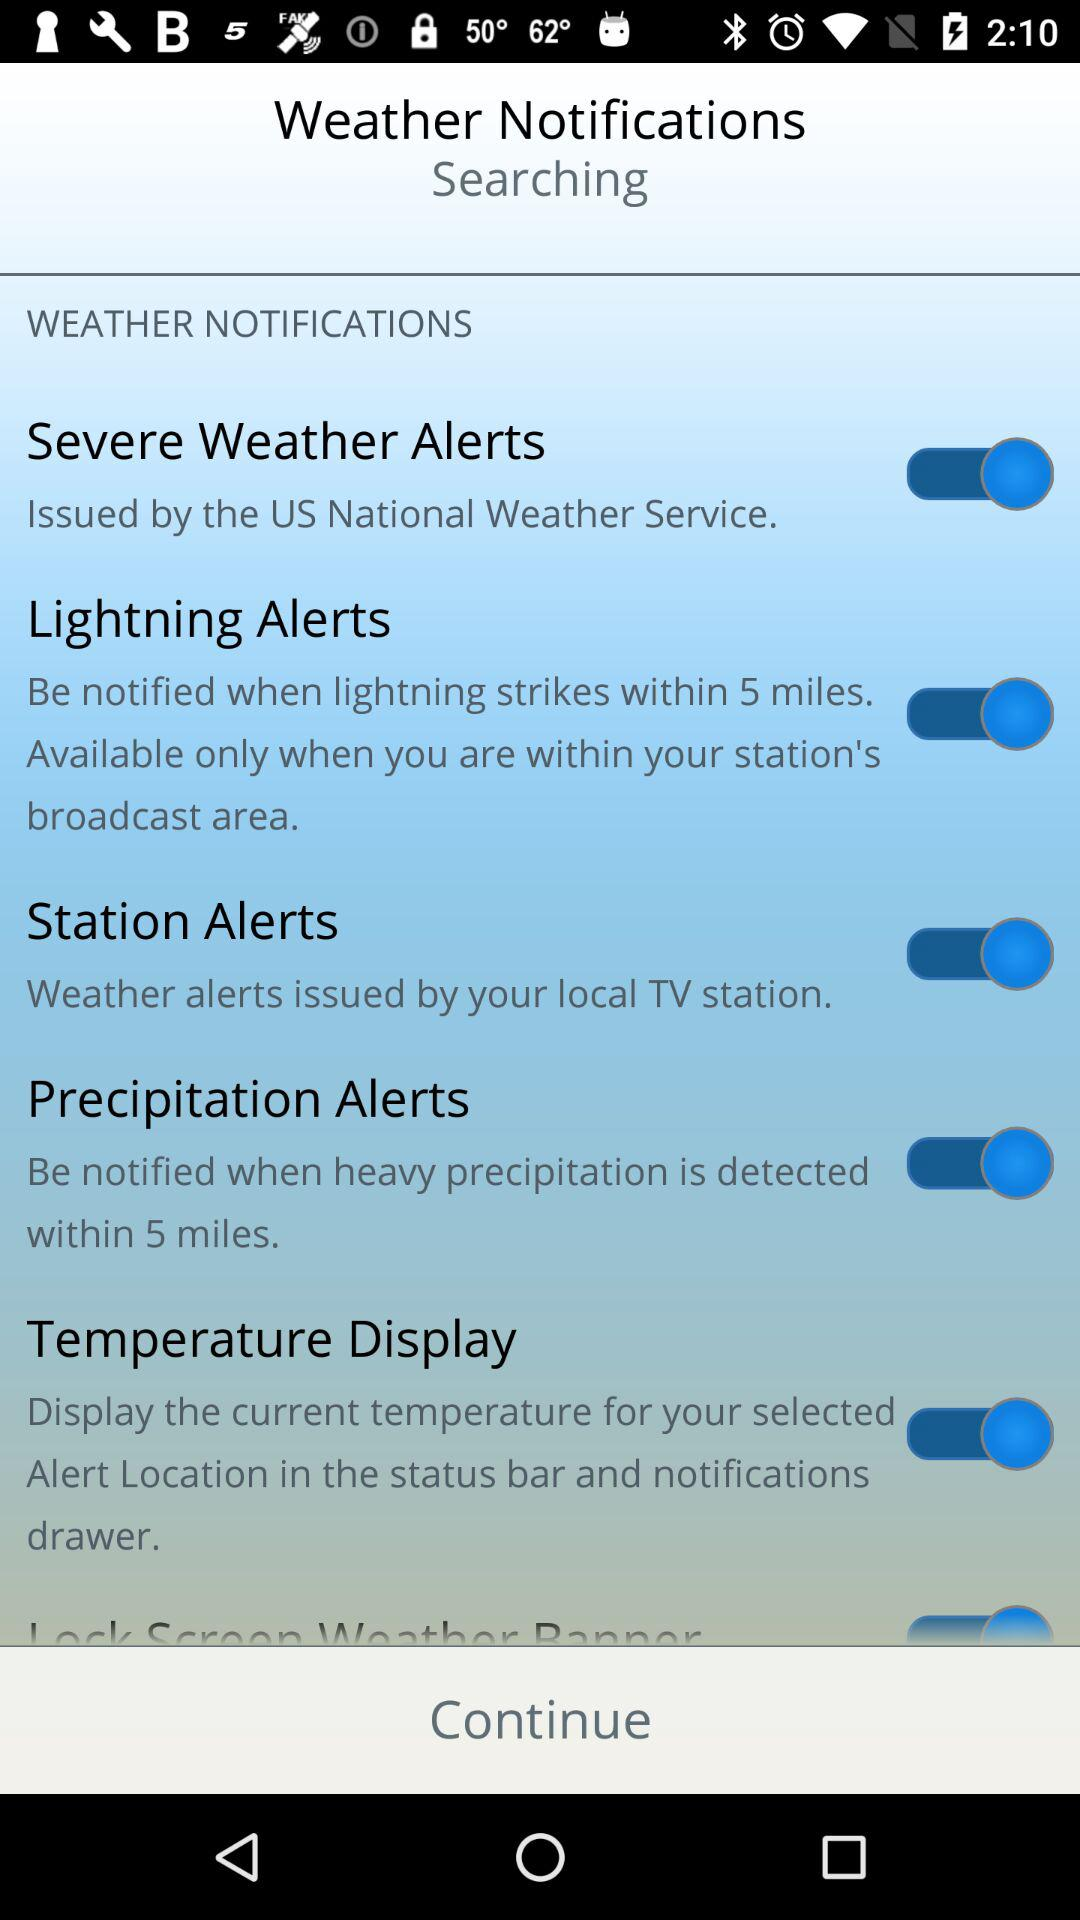Within what range does the precipitation alert generate? The range is 5 miles. 